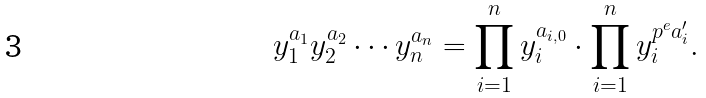Convert formula to latex. <formula><loc_0><loc_0><loc_500><loc_500>y _ { 1 } ^ { a _ { 1 } } y _ { 2 } ^ { a _ { 2 } } \cdots y _ { n } ^ { a _ { n } } = \prod _ { i = 1 } ^ { n } y _ { i } ^ { a _ { i , 0 } } \cdot \prod _ { i = 1 } ^ { n } y _ { i } ^ { p ^ { e } a _ { i } ^ { \prime } } .</formula> 